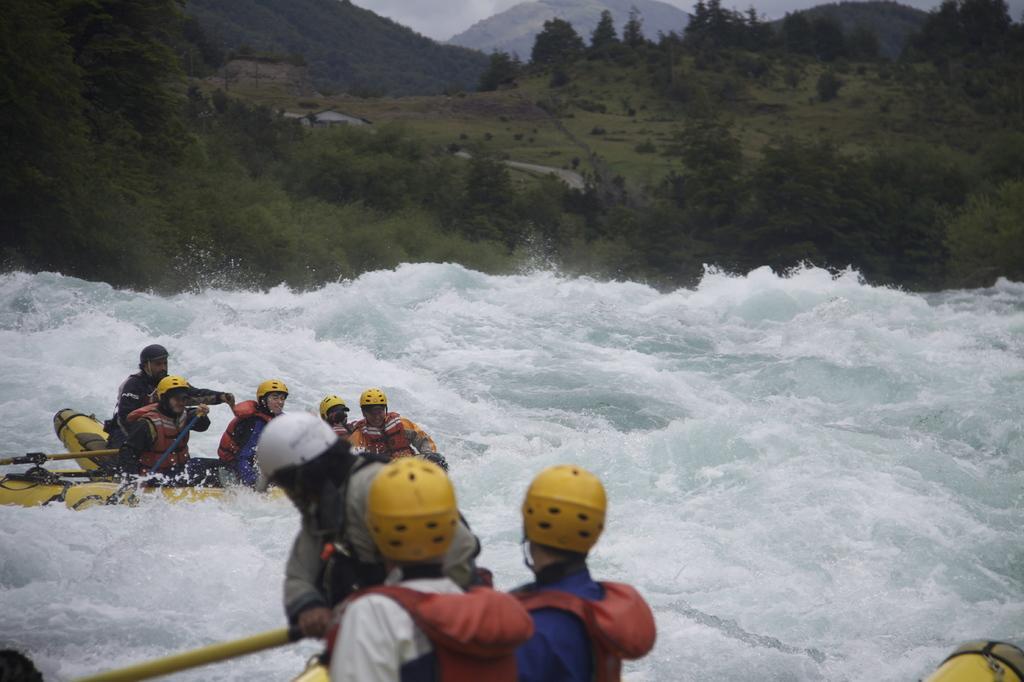Describe this image in one or two sentences. In this image I can see group of people boating on the water. The boat is in yellow color and they are holding few sticks, background I can see trees in green color and the sky is in white color. 